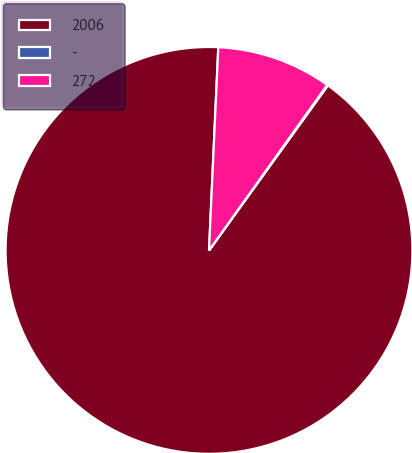<chart> <loc_0><loc_0><loc_500><loc_500><pie_chart><fcel>2006<fcel>-<fcel>272<nl><fcel>90.78%<fcel>0.07%<fcel>9.14%<nl></chart> 